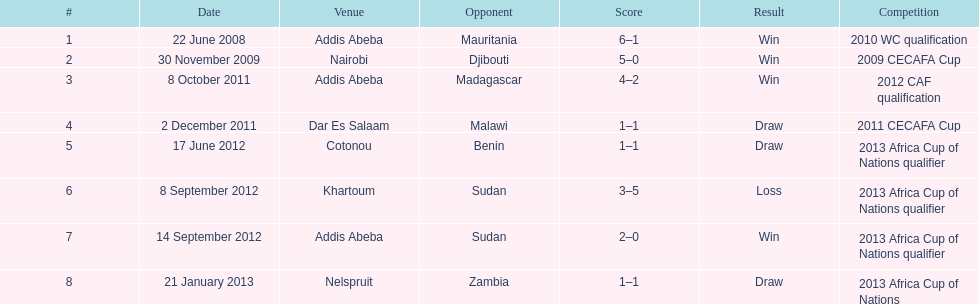What is the date of their single loss? 8 September 2012. 